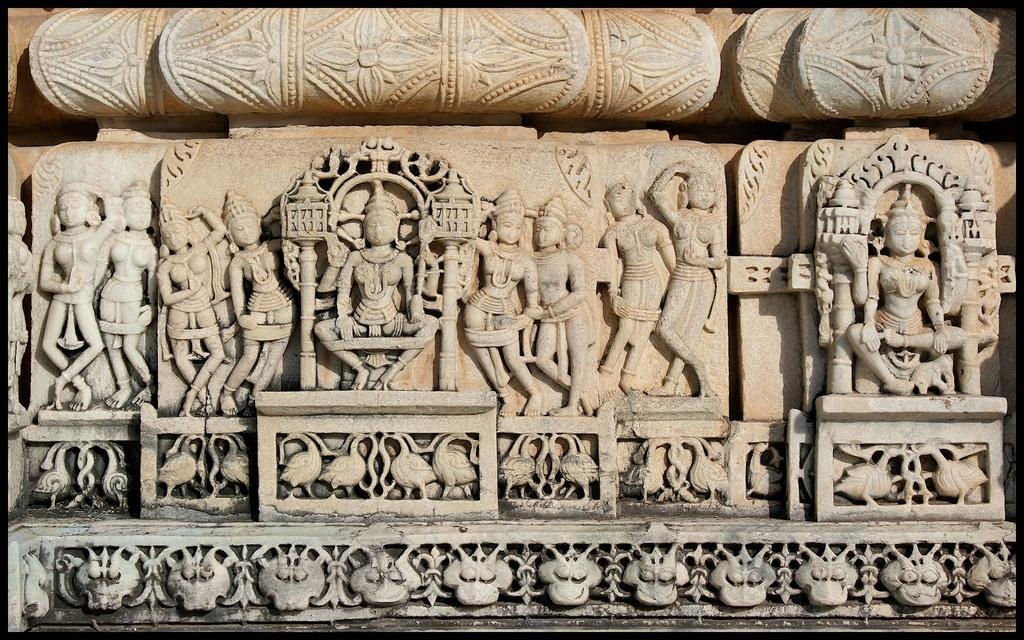Describe this image in one or two sentences. In this picture I can observe some carvings on the wall. This wall is in cream color. On the bottom of the picture I can observe a design on the wall. 